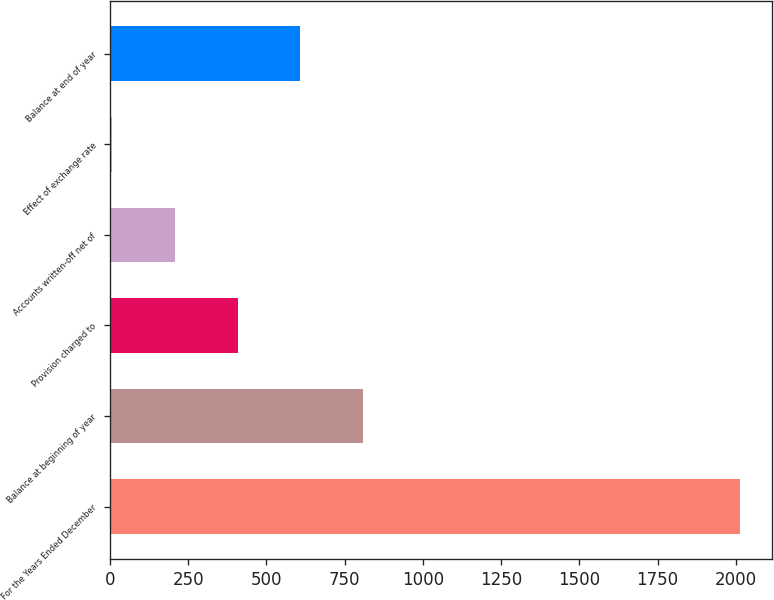Convert chart to OTSL. <chart><loc_0><loc_0><loc_500><loc_500><bar_chart><fcel>For the Years Ended December<fcel>Balance at beginning of year<fcel>Provision charged to<fcel>Accounts written-off net of<fcel>Effect of exchange rate<fcel>Balance at end of year<nl><fcel>2014<fcel>809.2<fcel>407.6<fcel>206.8<fcel>6<fcel>608.4<nl></chart> 